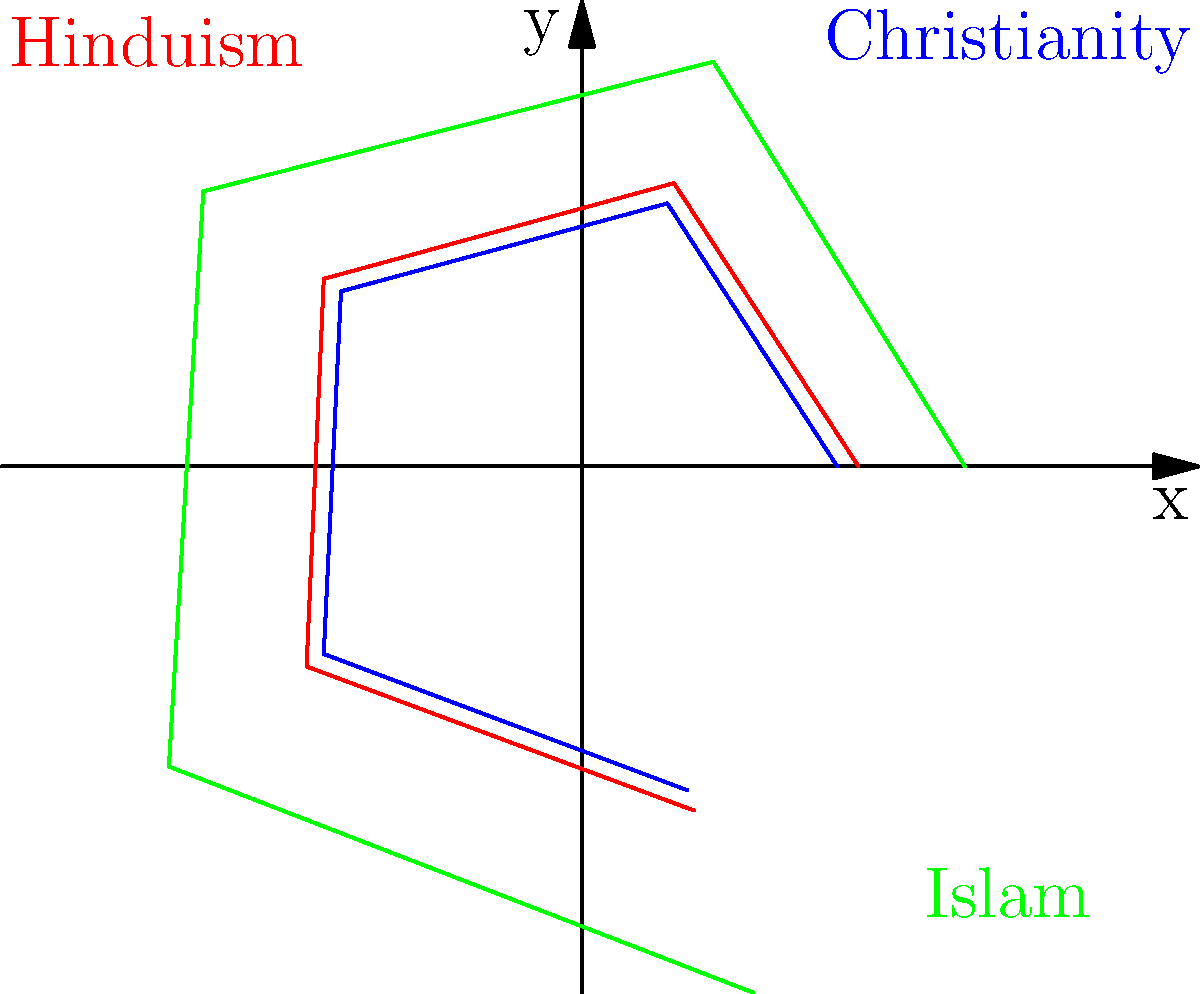Based on the spiral plots representing population growth rates of different religious groups over five time periods, which group shows the highest overall growth rate and what sociopolitical implications might this have? To answer this question, we need to analyze the spiral plots and interpret their sociopolitical implications:

1. Interpret the spiral plots:
   - Each spiral represents a religious group's growth rate over five time periods.
   - The distance from the center indicates the growth rate, with larger distances representing higher rates.
   - The blue spiral represents Christianity, green represents Islam, and red represents Hinduism.

2. Compare the growth rates:
   - Islam (green) has the largest spiral, indicating the highest overall growth rate.
   - Christianity (blue) and Hinduism (red) have smaller spirals, suggesting lower growth rates.

3. Analyze the growth patterns:
   - Islam's growth rate is consistently higher across all time periods.
   - Christianity and Hinduism show more moderate growth rates.

4. Sociopolitical implications:
   a) Demographic shifts: Faster growth of the Muslim population may lead to changes in religious demographics in various regions.
   b) Political representation: Increased Muslim populations may result in greater political influence and representation in some areas.
   c) Cultural adaptation: Societies may need to adapt to accommodate the growing Muslim population's needs and practices.
   d) Economic impacts: Changing demographics may influence labor markets, consumer behaviors, and economic policies.
   e) Education and social services: There may be increased demand for Islamic education and culturally sensitive social services.
   f) Potential for social tensions: Rapid demographic changes could lead to social tensions or conflicts in some regions.
   g) International relations: Countries with growing Muslim populations may shift their foreign policies or alliances.

5. Consider long-term effects:
   - The compounding effect of higher growth rates over time can lead to significant changes in religious landscapes and societal structures.

In conclusion, Islam shows the highest overall growth rate, which could have far-reaching sociopolitical implications affecting demographics, politics, culture, and international relations.
Answer: Islam; potential demographic shifts, increased political influence, cultural adaptation, and socioeconomic changes. 